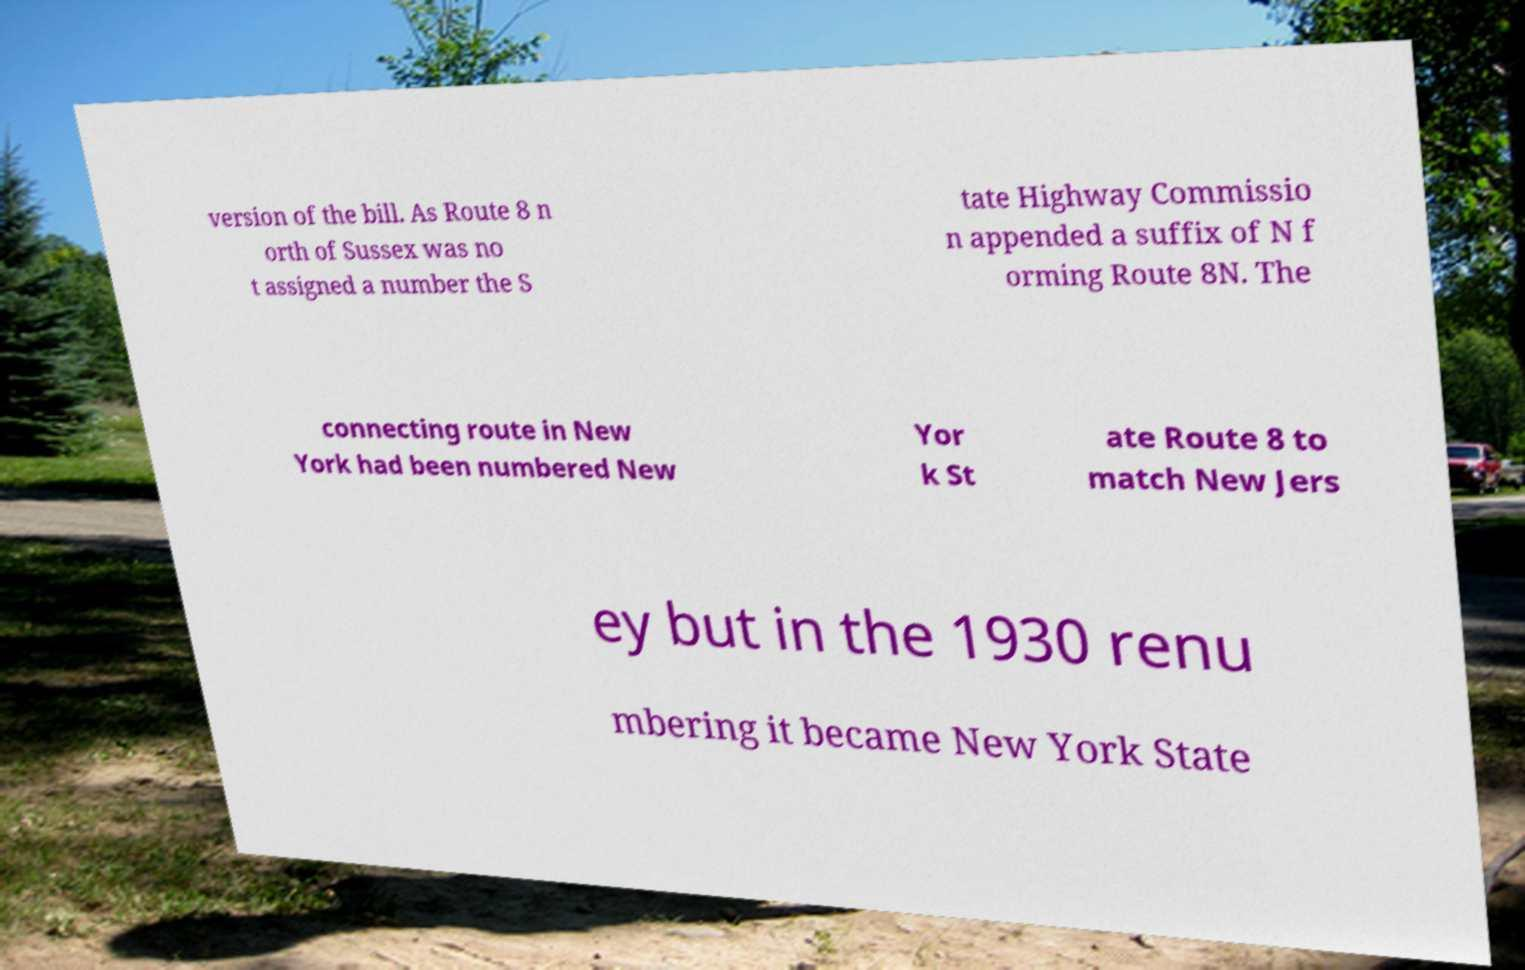Please read and relay the text visible in this image. What does it say? version of the bill. As Route 8 n orth of Sussex was no t assigned a number the S tate Highway Commissio n appended a suffix of N f orming Route 8N. The connecting route in New York had been numbered New Yor k St ate Route 8 to match New Jers ey but in the 1930 renu mbering it became New York State 